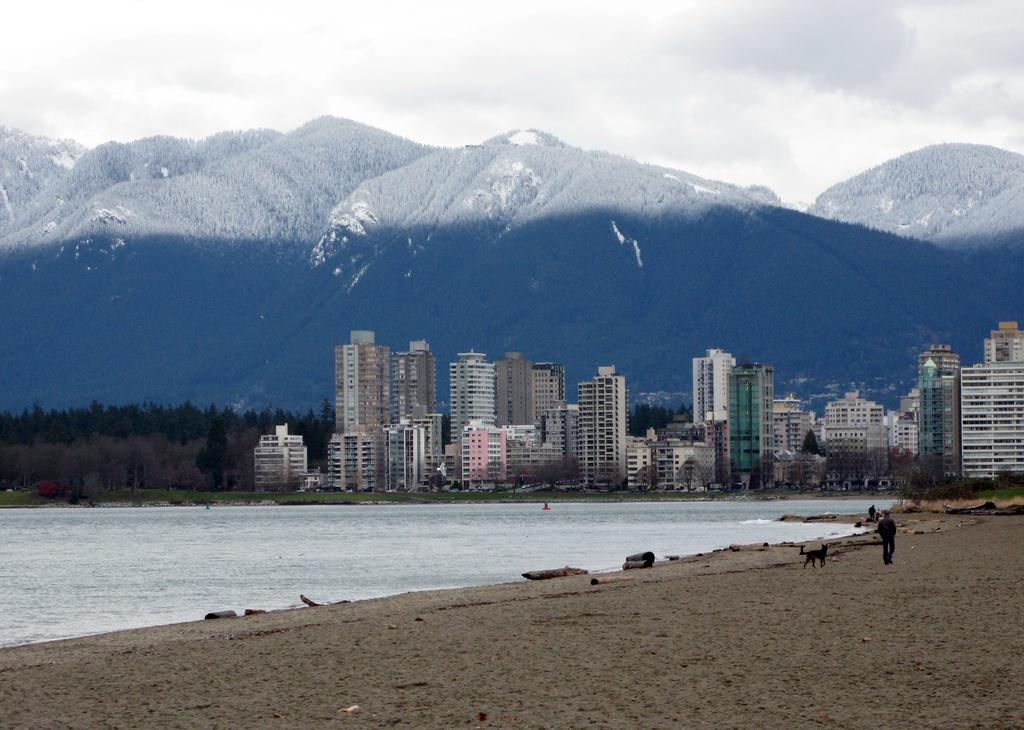What is the person in the image doing? There is a person walking in the image. What type of terrain can be seen in the image? There is sand in the image, and grass is also present. What natural elements are visible in the image? Water, trees, hills, and the sky are visible in the image. What is the weather like in the image? Clouds are present in the sky, indicating that it might be partly cloudy. What structures can be seen in the background of the image? There are buildings in the background of the image. How many clovers are visible in the image? There are no clovers present in the image. What type of force is being exerted by the person walking in the image? The person walking is not exerting any force in the image; they are simply walking. 